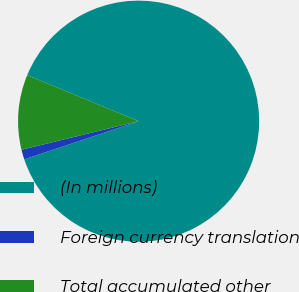Convert chart. <chart><loc_0><loc_0><loc_500><loc_500><pie_chart><fcel>(In millions)<fcel>Foreign currency translation<fcel>Total accumulated other<nl><fcel>88.63%<fcel>1.32%<fcel>10.05%<nl></chart> 